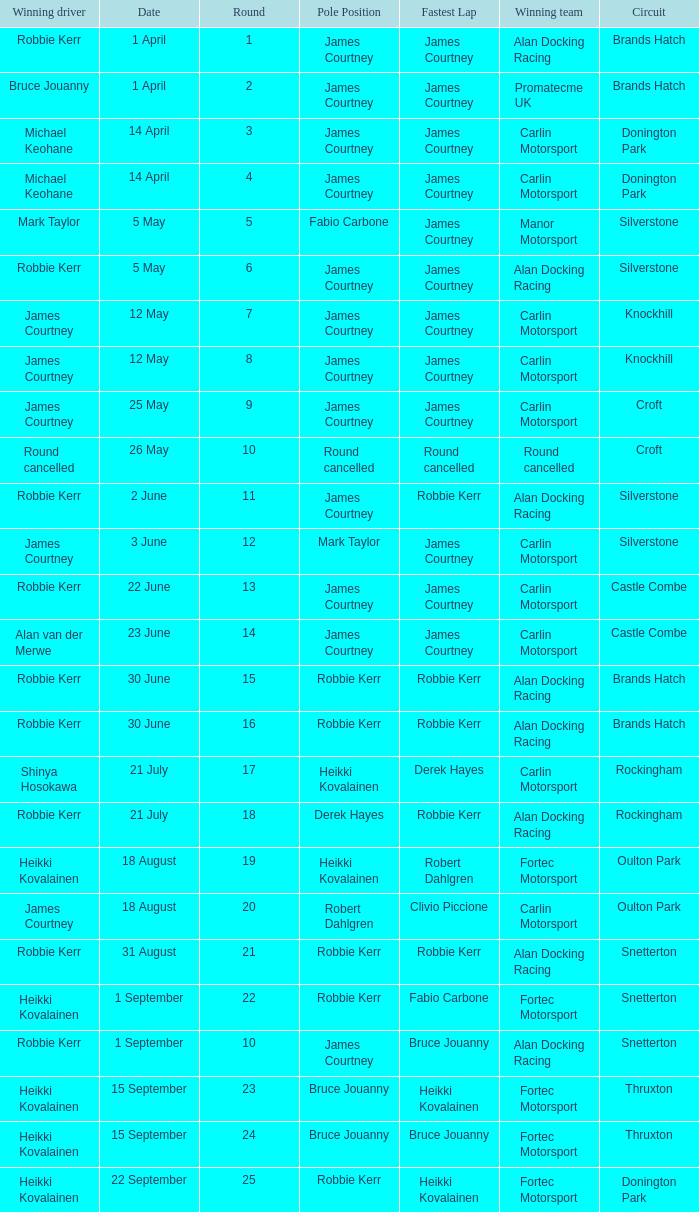How many pole positions for round 20? 1.0. Can you give me this table as a dict? {'header': ['Winning driver', 'Date', 'Round', 'Pole Position', 'Fastest Lap', 'Winning team', 'Circuit'], 'rows': [['Robbie Kerr', '1 April', '1', 'James Courtney', 'James Courtney', 'Alan Docking Racing', 'Brands Hatch'], ['Bruce Jouanny', '1 April', '2', 'James Courtney', 'James Courtney', 'Promatecme UK', 'Brands Hatch'], ['Michael Keohane', '14 April', '3', 'James Courtney', 'James Courtney', 'Carlin Motorsport', 'Donington Park'], ['Michael Keohane', '14 April', '4', 'James Courtney', 'James Courtney', 'Carlin Motorsport', 'Donington Park'], ['Mark Taylor', '5 May', '5', 'Fabio Carbone', 'James Courtney', 'Manor Motorsport', 'Silverstone'], ['Robbie Kerr', '5 May', '6', 'James Courtney', 'James Courtney', 'Alan Docking Racing', 'Silverstone'], ['James Courtney', '12 May', '7', 'James Courtney', 'James Courtney', 'Carlin Motorsport', 'Knockhill'], ['James Courtney', '12 May', '8', 'James Courtney', 'James Courtney', 'Carlin Motorsport', 'Knockhill'], ['James Courtney', '25 May', '9', 'James Courtney', 'James Courtney', 'Carlin Motorsport', 'Croft'], ['Round cancelled', '26 May', '10', 'Round cancelled', 'Round cancelled', 'Round cancelled', 'Croft'], ['Robbie Kerr', '2 June', '11', 'James Courtney', 'Robbie Kerr', 'Alan Docking Racing', 'Silverstone'], ['James Courtney', '3 June', '12', 'Mark Taylor', 'James Courtney', 'Carlin Motorsport', 'Silverstone'], ['Robbie Kerr', '22 June', '13', 'James Courtney', 'James Courtney', 'Carlin Motorsport', 'Castle Combe'], ['Alan van der Merwe', '23 June', '14', 'James Courtney', 'James Courtney', 'Carlin Motorsport', 'Castle Combe'], ['Robbie Kerr', '30 June', '15', 'Robbie Kerr', 'Robbie Kerr', 'Alan Docking Racing', 'Brands Hatch'], ['Robbie Kerr', '30 June', '16', 'Robbie Kerr', 'Robbie Kerr', 'Alan Docking Racing', 'Brands Hatch'], ['Shinya Hosokawa', '21 July', '17', 'Heikki Kovalainen', 'Derek Hayes', 'Carlin Motorsport', 'Rockingham'], ['Robbie Kerr', '21 July', '18', 'Derek Hayes', 'Robbie Kerr', 'Alan Docking Racing', 'Rockingham'], ['Heikki Kovalainen', '18 August', '19', 'Heikki Kovalainen', 'Robert Dahlgren', 'Fortec Motorsport', 'Oulton Park'], ['James Courtney', '18 August', '20', 'Robert Dahlgren', 'Clivio Piccione', 'Carlin Motorsport', 'Oulton Park'], ['Robbie Kerr', '31 August', '21', 'Robbie Kerr', 'Robbie Kerr', 'Alan Docking Racing', 'Snetterton'], ['Heikki Kovalainen', '1 September', '22', 'Robbie Kerr', 'Fabio Carbone', 'Fortec Motorsport', 'Snetterton'], ['Robbie Kerr', '1 September', '10', 'James Courtney', 'Bruce Jouanny', 'Alan Docking Racing', 'Snetterton'], ['Heikki Kovalainen', '15 September', '23', 'Bruce Jouanny', 'Heikki Kovalainen', 'Fortec Motorsport', 'Thruxton'], ['Heikki Kovalainen', '15 September', '24', 'Bruce Jouanny', 'Bruce Jouanny', 'Fortec Motorsport', 'Thruxton'], ['Heikki Kovalainen', '22 September', '25', 'Robbie Kerr', 'Heikki Kovalainen', 'Fortec Motorsport', 'Donington Park']]} 